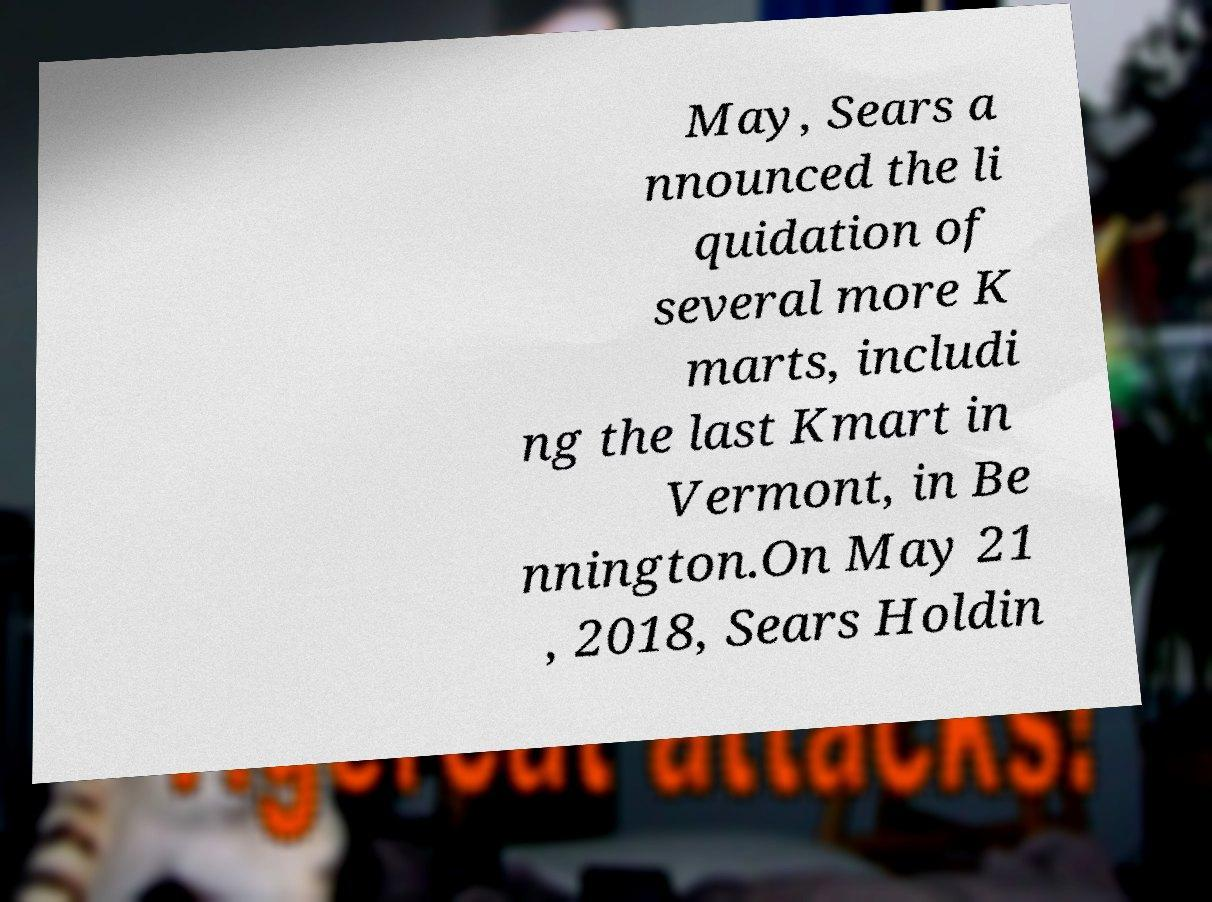Can you read and provide the text displayed in the image?This photo seems to have some interesting text. Can you extract and type it out for me? May, Sears a nnounced the li quidation of several more K marts, includi ng the last Kmart in Vermont, in Be nnington.On May 21 , 2018, Sears Holdin 